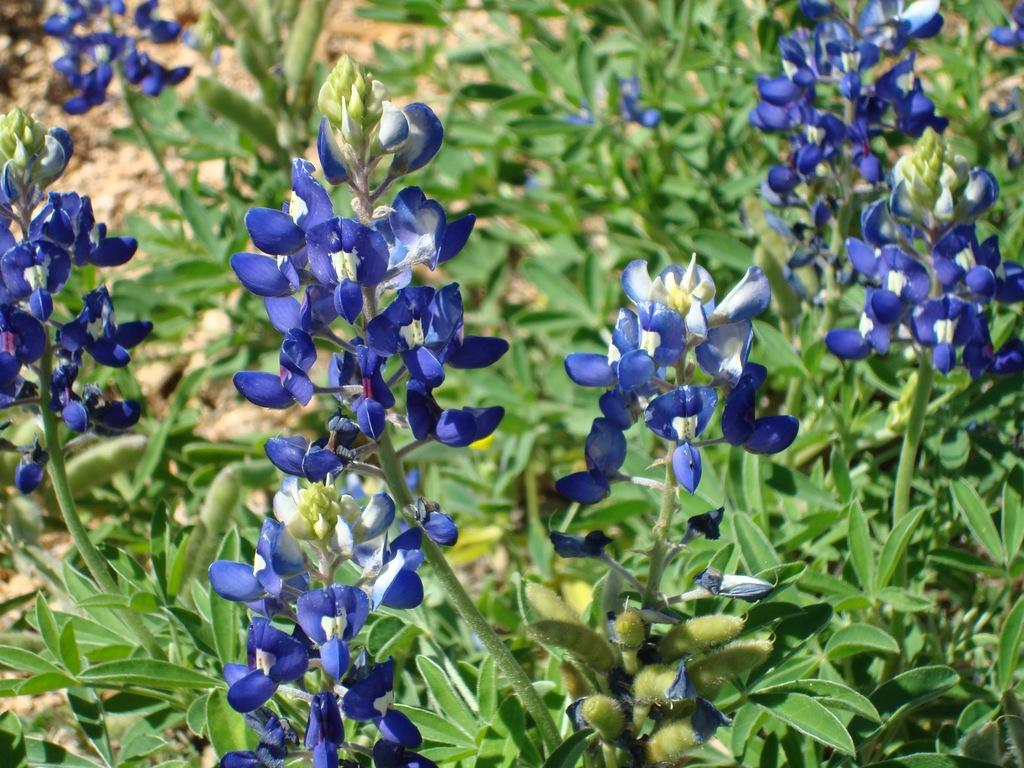What color are the flowers in the image? The flowers in the image are blue. What can be seen in the background of the image? There are plants in the background of the image. What type of cake is being served on the table in the image? There is no table or cake present in the image; it features blue color flowers and plants in the background. How many cards are visible on the ground in the image? There are no cards visible in the image; it features blue color flowers and plants in the background. 